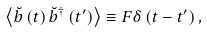Convert formula to latex. <formula><loc_0><loc_0><loc_500><loc_500>\left \langle \breve { b } \left ( t \right ) \breve { b } ^ { \dag } \left ( t ^ { \prime } \right ) \right \rangle \equiv F \delta \left ( t - t ^ { \prime } \right ) ,</formula> 